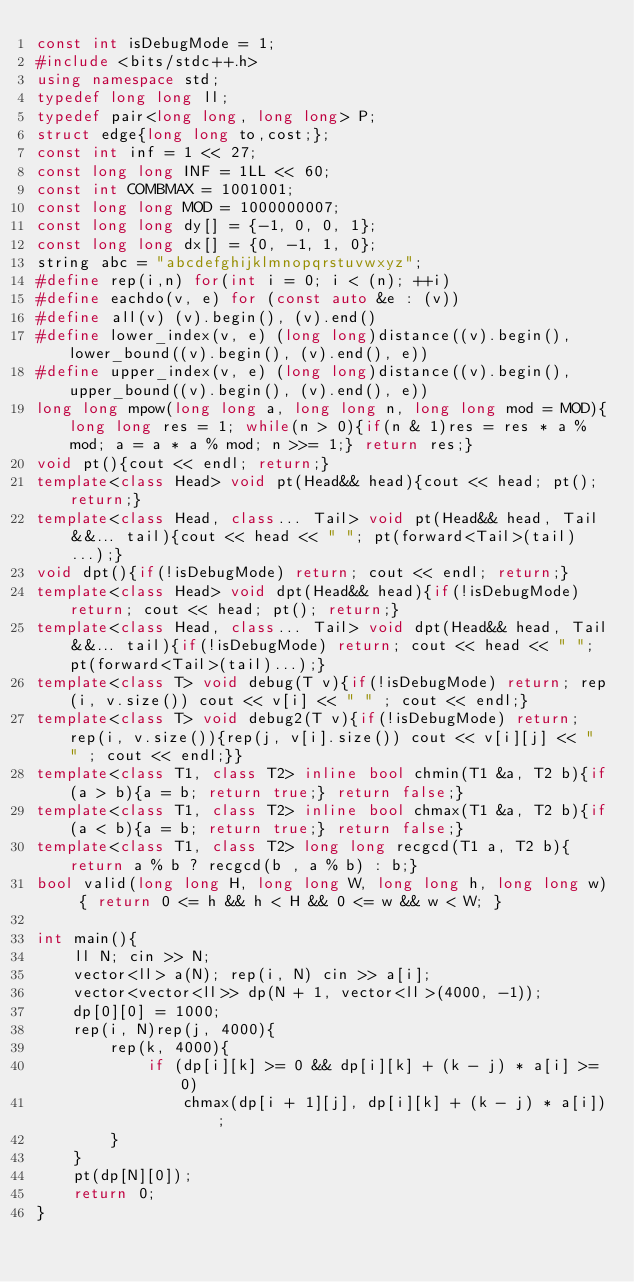Convert code to text. <code><loc_0><loc_0><loc_500><loc_500><_C++_>const int isDebugMode = 1;
#include <bits/stdc++.h>
using namespace std;
typedef long long ll;
typedef pair<long long, long long> P;
struct edge{long long to,cost;};
const int inf = 1 << 27;
const long long INF = 1LL << 60;
const int COMBMAX = 1001001;
const long long MOD = 1000000007;
const long long dy[] = {-1, 0, 0, 1};
const long long dx[] = {0, -1, 1, 0};
string abc = "abcdefghijklmnopqrstuvwxyz";
#define rep(i,n) for(int i = 0; i < (n); ++i)
#define eachdo(v, e) for (const auto &e : (v))
#define all(v) (v).begin(), (v).end()
#define lower_index(v, e) (long long)distance((v).begin(), lower_bound((v).begin(), (v).end(), e))
#define upper_index(v, e) (long long)distance((v).begin(), upper_bound((v).begin(), (v).end(), e))
long long mpow(long long a, long long n, long long mod = MOD){long long res = 1; while(n > 0){if(n & 1)res = res * a % mod; a = a * a % mod; n >>= 1;} return res;}
void pt(){cout << endl; return;}
template<class Head> void pt(Head&& head){cout << head; pt(); return;}
template<class Head, class... Tail> void pt(Head&& head, Tail&&... tail){cout << head << " "; pt(forward<Tail>(tail)...);}
void dpt(){if(!isDebugMode) return; cout << endl; return;}
template<class Head> void dpt(Head&& head){if(!isDebugMode) return; cout << head; pt(); return;}
template<class Head, class... Tail> void dpt(Head&& head, Tail&&... tail){if(!isDebugMode) return; cout << head << " "; pt(forward<Tail>(tail)...);}
template<class T> void debug(T v){if(!isDebugMode) return; rep(i, v.size()) cout << v[i] << " " ; cout << endl;}
template<class T> void debug2(T v){if(!isDebugMode) return; rep(i, v.size()){rep(j, v[i].size()) cout << v[i][j] << " " ; cout << endl;}}
template<class T1, class T2> inline bool chmin(T1 &a, T2 b){if(a > b){a = b; return true;} return false;}
template<class T1, class T2> inline bool chmax(T1 &a, T2 b){if(a < b){a = b; return true;} return false;}
template<class T1, class T2> long long recgcd(T1 a, T2 b){return a % b ? recgcd(b , a % b) : b;}
bool valid(long long H, long long W, long long h, long long w) { return 0 <= h && h < H && 0 <= w && w < W; }

int main(){
    ll N; cin >> N;
    vector<ll> a(N); rep(i, N) cin >> a[i];
    vector<vector<ll>> dp(N + 1, vector<ll>(4000, -1));
    dp[0][0] = 1000;
    rep(i, N)rep(j, 4000){
        rep(k, 4000){
            if (dp[i][k] >= 0 && dp[i][k] + (k - j) * a[i] >= 0)
                chmax(dp[i + 1][j], dp[i][k] + (k - j) * a[i]);
        }
    }
    pt(dp[N][0]);
    return 0;
}</code> 